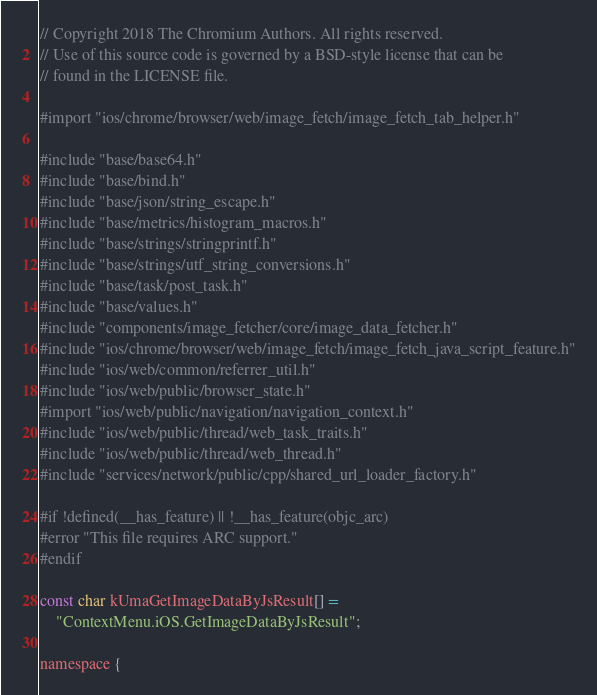<code> <loc_0><loc_0><loc_500><loc_500><_ObjectiveC_>// Copyright 2018 The Chromium Authors. All rights reserved.
// Use of this source code is governed by a BSD-style license that can be
// found in the LICENSE file.

#import "ios/chrome/browser/web/image_fetch/image_fetch_tab_helper.h"

#include "base/base64.h"
#include "base/bind.h"
#include "base/json/string_escape.h"
#include "base/metrics/histogram_macros.h"
#include "base/strings/stringprintf.h"
#include "base/strings/utf_string_conversions.h"
#include "base/task/post_task.h"
#include "base/values.h"
#include "components/image_fetcher/core/image_data_fetcher.h"
#include "ios/chrome/browser/web/image_fetch/image_fetch_java_script_feature.h"
#include "ios/web/common/referrer_util.h"
#include "ios/web/public/browser_state.h"
#import "ios/web/public/navigation/navigation_context.h"
#include "ios/web/public/thread/web_task_traits.h"
#include "ios/web/public/thread/web_thread.h"
#include "services/network/public/cpp/shared_url_loader_factory.h"

#if !defined(__has_feature) || !__has_feature(objc_arc)
#error "This file requires ARC support."
#endif

const char kUmaGetImageDataByJsResult[] =
    "ContextMenu.iOS.GetImageDataByJsResult";

namespace {</code> 